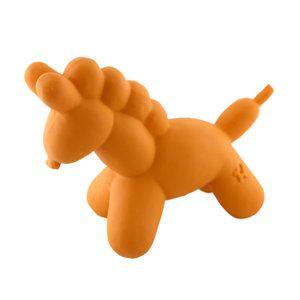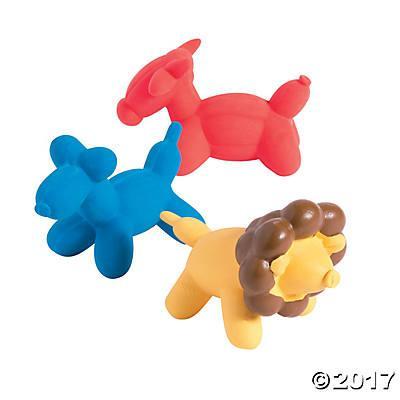The first image is the image on the left, the second image is the image on the right. Evaluate the accuracy of this statement regarding the images: "One of the balloons is the shape of a lion.". Is it true? Answer yes or no. Yes. 